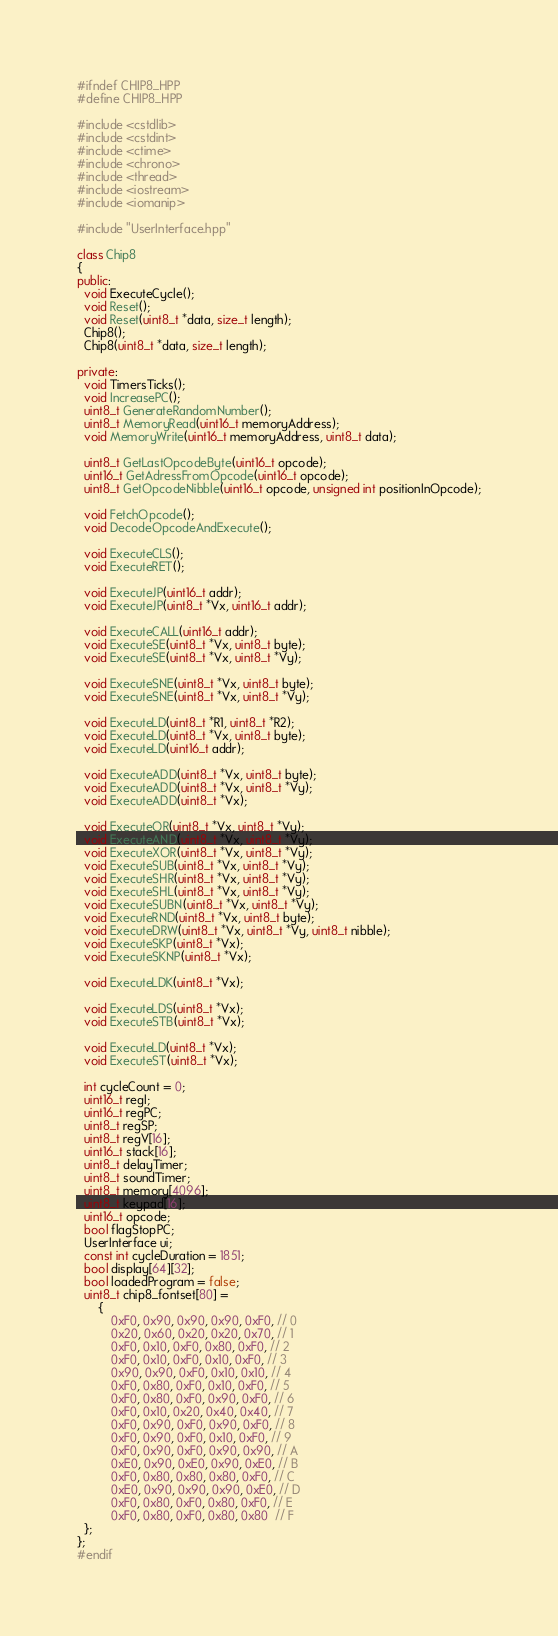Convert code to text. <code><loc_0><loc_0><loc_500><loc_500><_C++_>#ifndef CHIP8_HPP
#define CHIP8_HPP

#include <cstdlib>
#include <cstdint>
#include <ctime>
#include <chrono>
#include <thread>
#include <iostream>
#include <iomanip>

#include "UserInterface.hpp"

class Chip8
{
public:
  void ExecuteCycle();
  void Reset();
  void Reset(uint8_t *data, size_t length);
  Chip8();
  Chip8(uint8_t *data, size_t length);

private:
  void TimersTicks();
  void IncreasePC();
  uint8_t GenerateRandomNumber();
  uint8_t MemoryRead(uint16_t memoryAddress);
  void MemoryWrite(uint16_t memoryAddress, uint8_t data);

  uint8_t GetLastOpcodeByte(uint16_t opcode);
  uint16_t GetAdressFromOpcode(uint16_t opcode);
  uint8_t GetOpcodeNibble(uint16_t opcode, unsigned int positionInOpcode);

  void FetchOpcode();
  void DecodeOpcodeAndExecute();

  void ExecuteCLS();
  void ExecuteRET();

  void ExecuteJP(uint16_t addr);
  void ExecuteJP(uint8_t *Vx, uint16_t addr);

  void ExecuteCALL(uint16_t addr);
  void ExecuteSE(uint8_t *Vx, uint8_t byte);
  void ExecuteSE(uint8_t *Vx, uint8_t *Vy);

  void ExecuteSNE(uint8_t *Vx, uint8_t byte);
  void ExecuteSNE(uint8_t *Vx, uint8_t *Vy);

  void ExecuteLD(uint8_t *R1, uint8_t *R2);
  void ExecuteLD(uint8_t *Vx, uint8_t byte);
  void ExecuteLD(uint16_t addr);

  void ExecuteADD(uint8_t *Vx, uint8_t byte);
  void ExecuteADD(uint8_t *Vx, uint8_t *Vy);
  void ExecuteADD(uint8_t *Vx);

  void ExecuteOR(uint8_t *Vx, uint8_t *Vy);
  void ExecuteAND(uint8_t *Vx, uint8_t *Vy);
  void ExecuteXOR(uint8_t *Vx, uint8_t *Vy);
  void ExecuteSUB(uint8_t *Vx, uint8_t *Vy);
  void ExecuteSHR(uint8_t *Vx, uint8_t *Vy);
  void ExecuteSHL(uint8_t *Vx, uint8_t *Vy);
  void ExecuteSUBN(uint8_t *Vx, uint8_t *Vy);
  void ExecuteRND(uint8_t *Vx, uint8_t byte);
  void ExecuteDRW(uint8_t *Vx, uint8_t *Vy, uint8_t nibble);
  void ExecuteSKP(uint8_t *Vx);
  void ExecuteSKNP(uint8_t *Vx);

  void ExecuteLDK(uint8_t *Vx);

  void ExecuteLDS(uint8_t *Vx);
  void ExecuteSTB(uint8_t *Vx);

  void ExecuteLD(uint8_t *Vx);
  void ExecuteST(uint8_t *Vx);

  int cycleCount = 0;
  uint16_t regI;
  uint16_t regPC;
  uint8_t regSP;
  uint8_t regV[16];
  uint16_t stack[16];
  uint8_t delayTimer;
  uint8_t soundTimer;
  uint8_t memory[4096];
  uint8_t keypad[16];
  uint16_t opcode;
  bool flagStopPC;
  UserInterface ui;
  const int cycleDuration = 1851;
  bool display[64][32];
  bool loadedProgram = false;
  uint8_t chip8_fontset[80] =
      {
          0xF0, 0x90, 0x90, 0x90, 0xF0, // 0
          0x20, 0x60, 0x20, 0x20, 0x70, // 1
          0xF0, 0x10, 0xF0, 0x80, 0xF0, // 2
          0xF0, 0x10, 0xF0, 0x10, 0xF0, // 3
          0x90, 0x90, 0xF0, 0x10, 0x10, // 4
          0xF0, 0x80, 0xF0, 0x10, 0xF0, // 5
          0xF0, 0x80, 0xF0, 0x90, 0xF0, // 6
          0xF0, 0x10, 0x20, 0x40, 0x40, // 7
          0xF0, 0x90, 0xF0, 0x90, 0xF0, // 8
          0xF0, 0x90, 0xF0, 0x10, 0xF0, // 9
          0xF0, 0x90, 0xF0, 0x90, 0x90, // A
          0xE0, 0x90, 0xE0, 0x90, 0xE0, // B
          0xF0, 0x80, 0x80, 0x80, 0xF0, // C
          0xE0, 0x90, 0x90, 0x90, 0xE0, // D
          0xF0, 0x80, 0xF0, 0x80, 0xF0, // E
          0xF0, 0x80, 0xF0, 0x80, 0x80  // F
  };
};
#endif</code> 